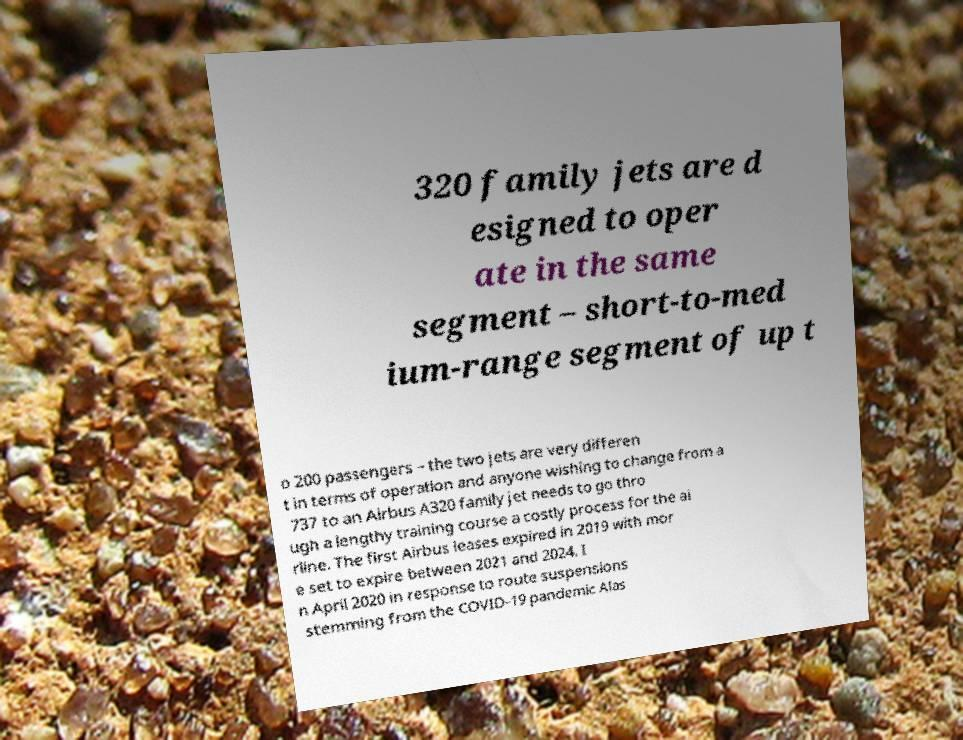Can you accurately transcribe the text from the provided image for me? 320 family jets are d esigned to oper ate in the same segment – short-to-med ium-range segment of up t o 200 passengers – the two jets are very differen t in terms of operation and anyone wishing to change from a 737 to an Airbus A320 family jet needs to go thro ugh a lengthy training course a costly process for the ai rline. The first Airbus leases expired in 2019 with mor e set to expire between 2021 and 2024. I n April 2020 in response to route suspensions stemming from the COVID-19 pandemic Alas 